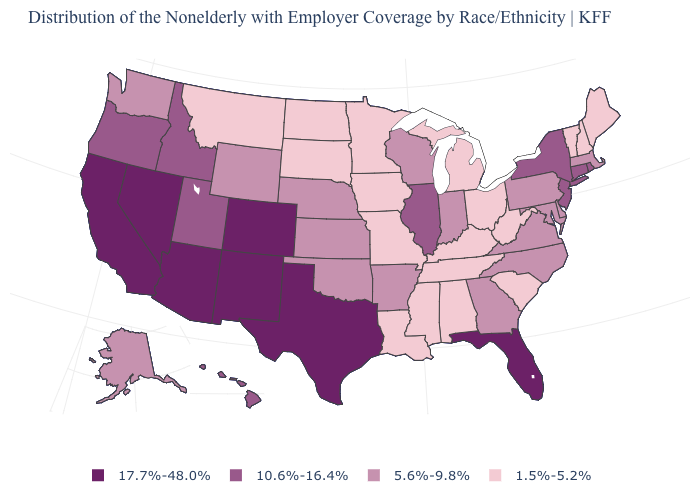Which states have the lowest value in the West?
Short answer required. Montana. Name the states that have a value in the range 5.6%-9.8%?
Keep it brief. Alaska, Arkansas, Delaware, Georgia, Indiana, Kansas, Maryland, Massachusetts, Nebraska, North Carolina, Oklahoma, Pennsylvania, Virginia, Washington, Wisconsin, Wyoming. What is the value of Maine?
Be succinct. 1.5%-5.2%. What is the highest value in states that border Pennsylvania?
Be succinct. 10.6%-16.4%. Name the states that have a value in the range 5.6%-9.8%?
Concise answer only. Alaska, Arkansas, Delaware, Georgia, Indiana, Kansas, Maryland, Massachusetts, Nebraska, North Carolina, Oklahoma, Pennsylvania, Virginia, Washington, Wisconsin, Wyoming. What is the value of Kansas?
Quick response, please. 5.6%-9.8%. What is the highest value in the USA?
Write a very short answer. 17.7%-48.0%. Does Rhode Island have a higher value than Hawaii?
Keep it brief. No. Does Virginia have the same value as Tennessee?
Write a very short answer. No. Name the states that have a value in the range 5.6%-9.8%?
Quick response, please. Alaska, Arkansas, Delaware, Georgia, Indiana, Kansas, Maryland, Massachusetts, Nebraska, North Carolina, Oklahoma, Pennsylvania, Virginia, Washington, Wisconsin, Wyoming. Name the states that have a value in the range 10.6%-16.4%?
Answer briefly. Connecticut, Hawaii, Idaho, Illinois, New Jersey, New York, Oregon, Rhode Island, Utah. Does Tennessee have a lower value than Alaska?
Quick response, please. Yes. What is the lowest value in the MidWest?
Short answer required. 1.5%-5.2%. What is the value of California?
Keep it brief. 17.7%-48.0%. What is the value of Tennessee?
Write a very short answer. 1.5%-5.2%. 